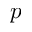<formula> <loc_0><loc_0><loc_500><loc_500>p</formula> 